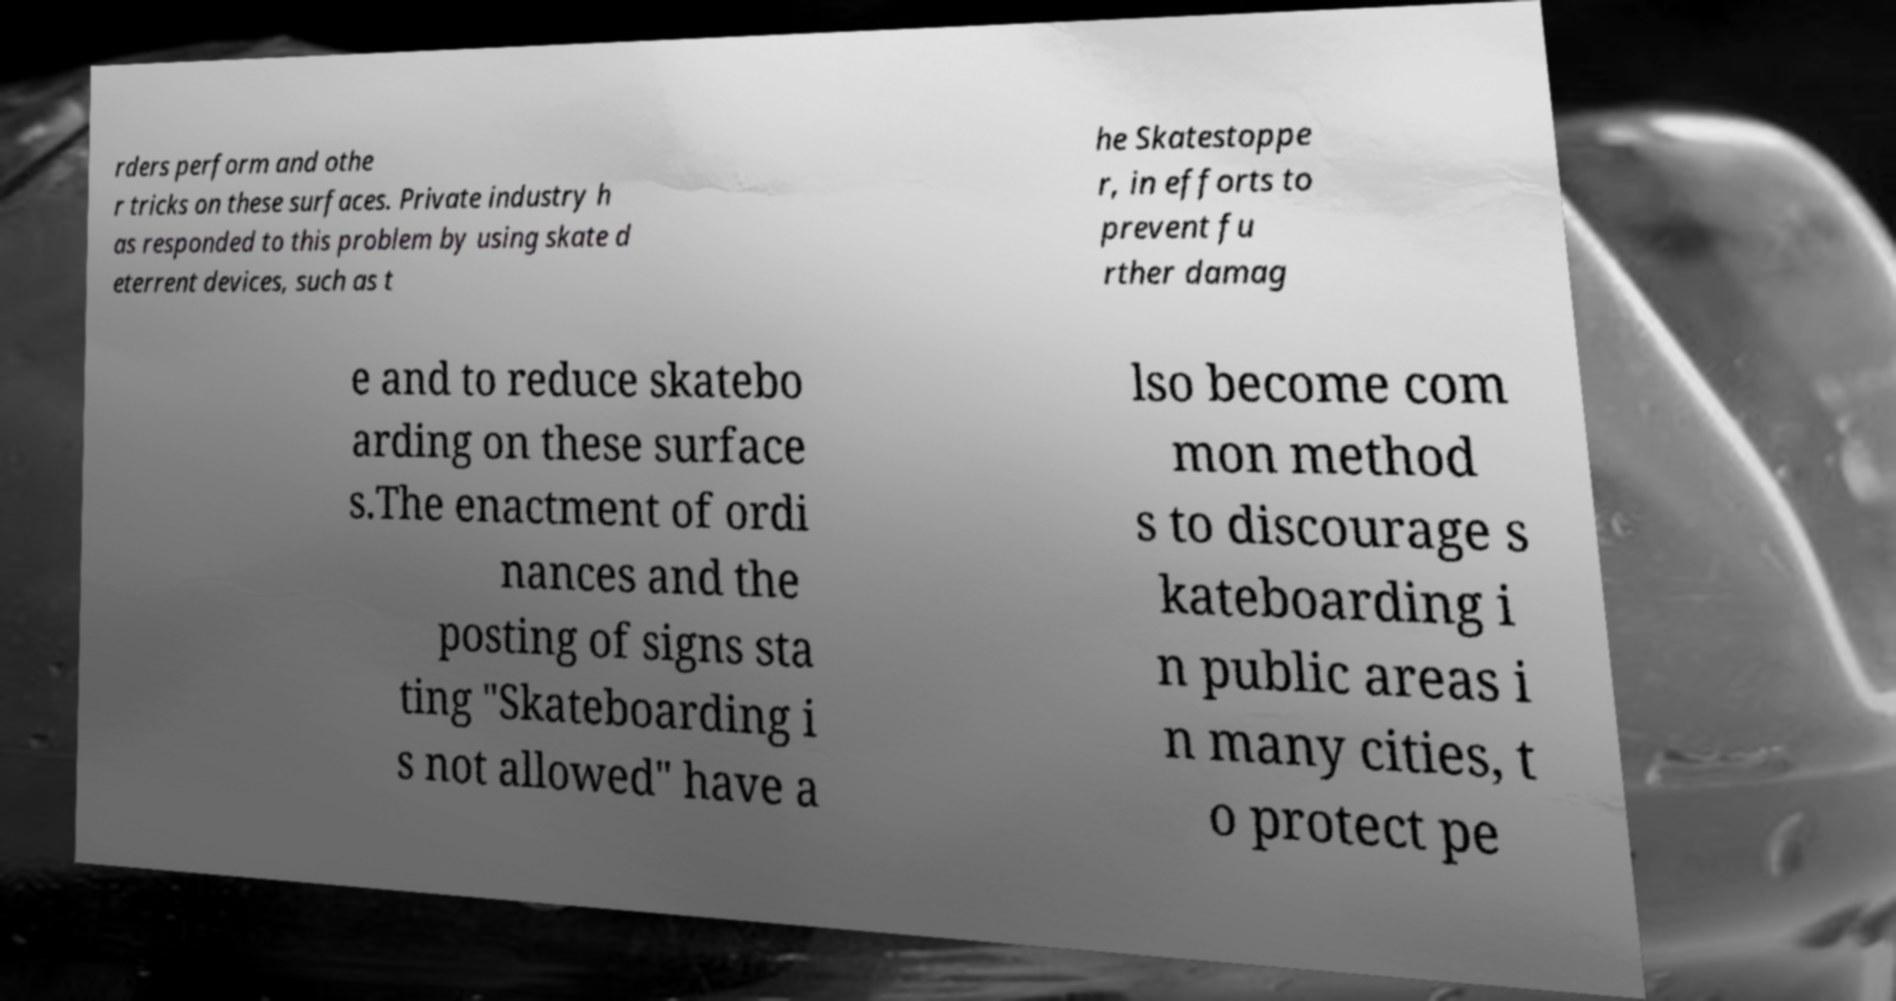There's text embedded in this image that I need extracted. Can you transcribe it verbatim? rders perform and othe r tricks on these surfaces. Private industry h as responded to this problem by using skate d eterrent devices, such as t he Skatestoppe r, in efforts to prevent fu rther damag e and to reduce skatebo arding on these surface s.The enactment of ordi nances and the posting of signs sta ting "Skateboarding i s not allowed" have a lso become com mon method s to discourage s kateboarding i n public areas i n many cities, t o protect pe 